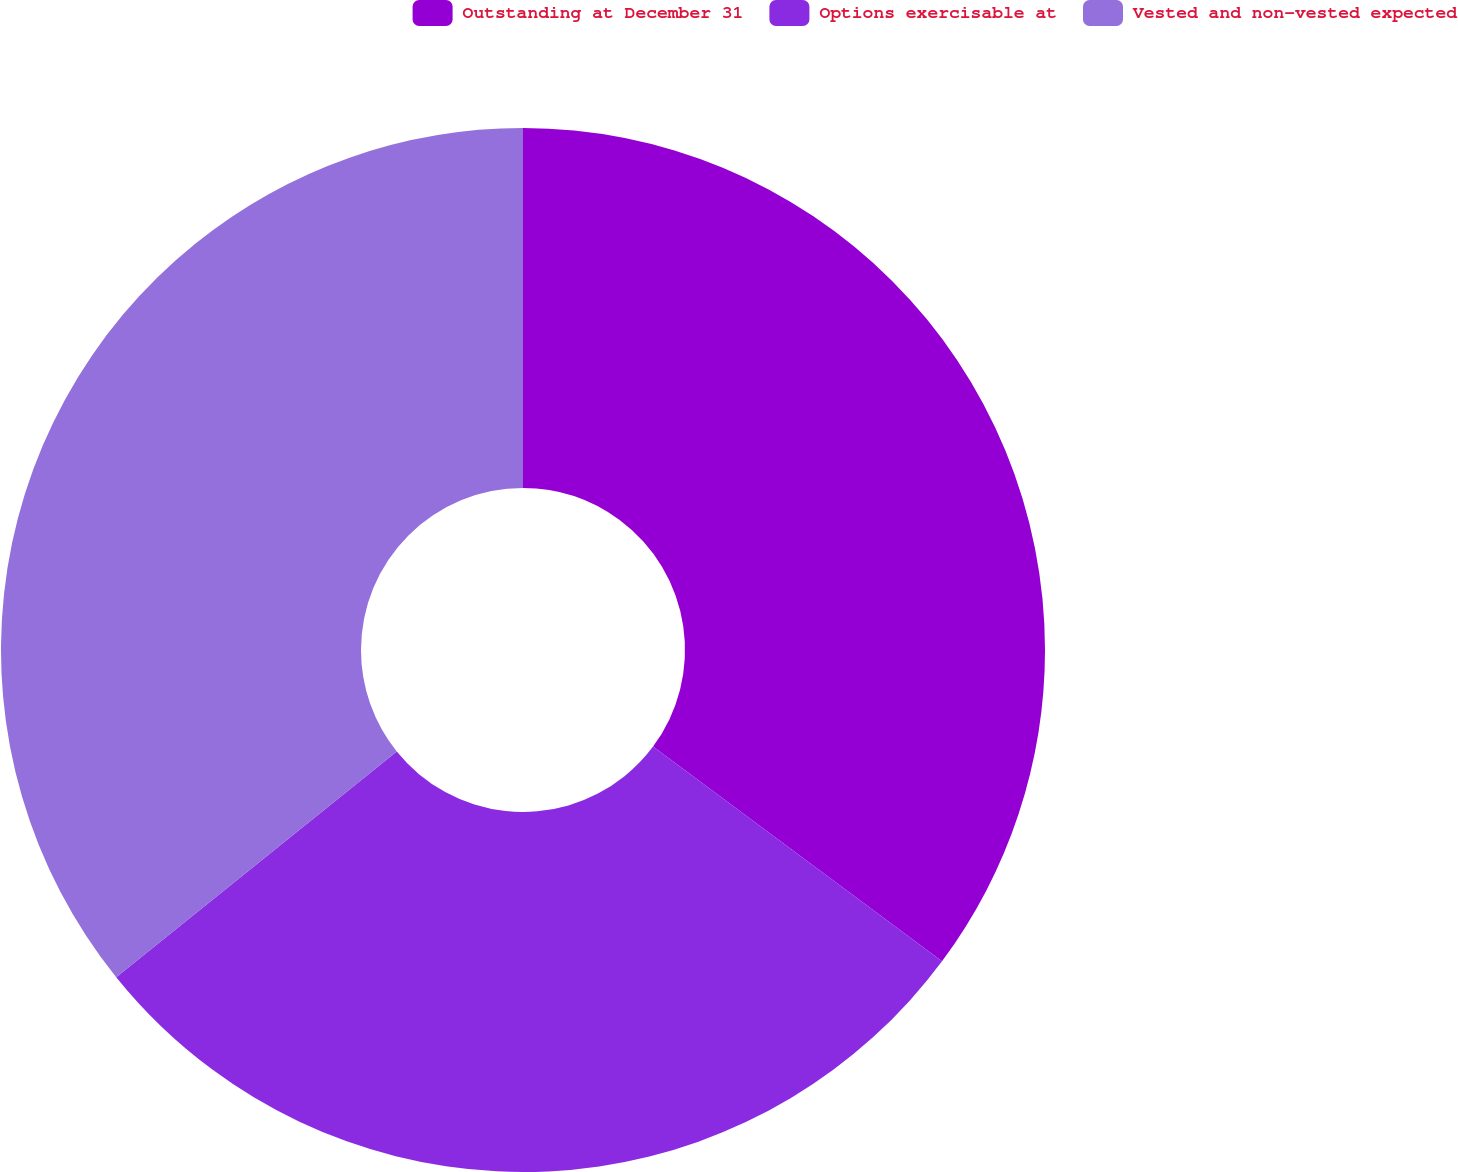Convert chart. <chart><loc_0><loc_0><loc_500><loc_500><pie_chart><fcel>Outstanding at December 31<fcel>Options exercisable at<fcel>Vested and non-vested expected<nl><fcel>35.17%<fcel>29.05%<fcel>35.78%<nl></chart> 